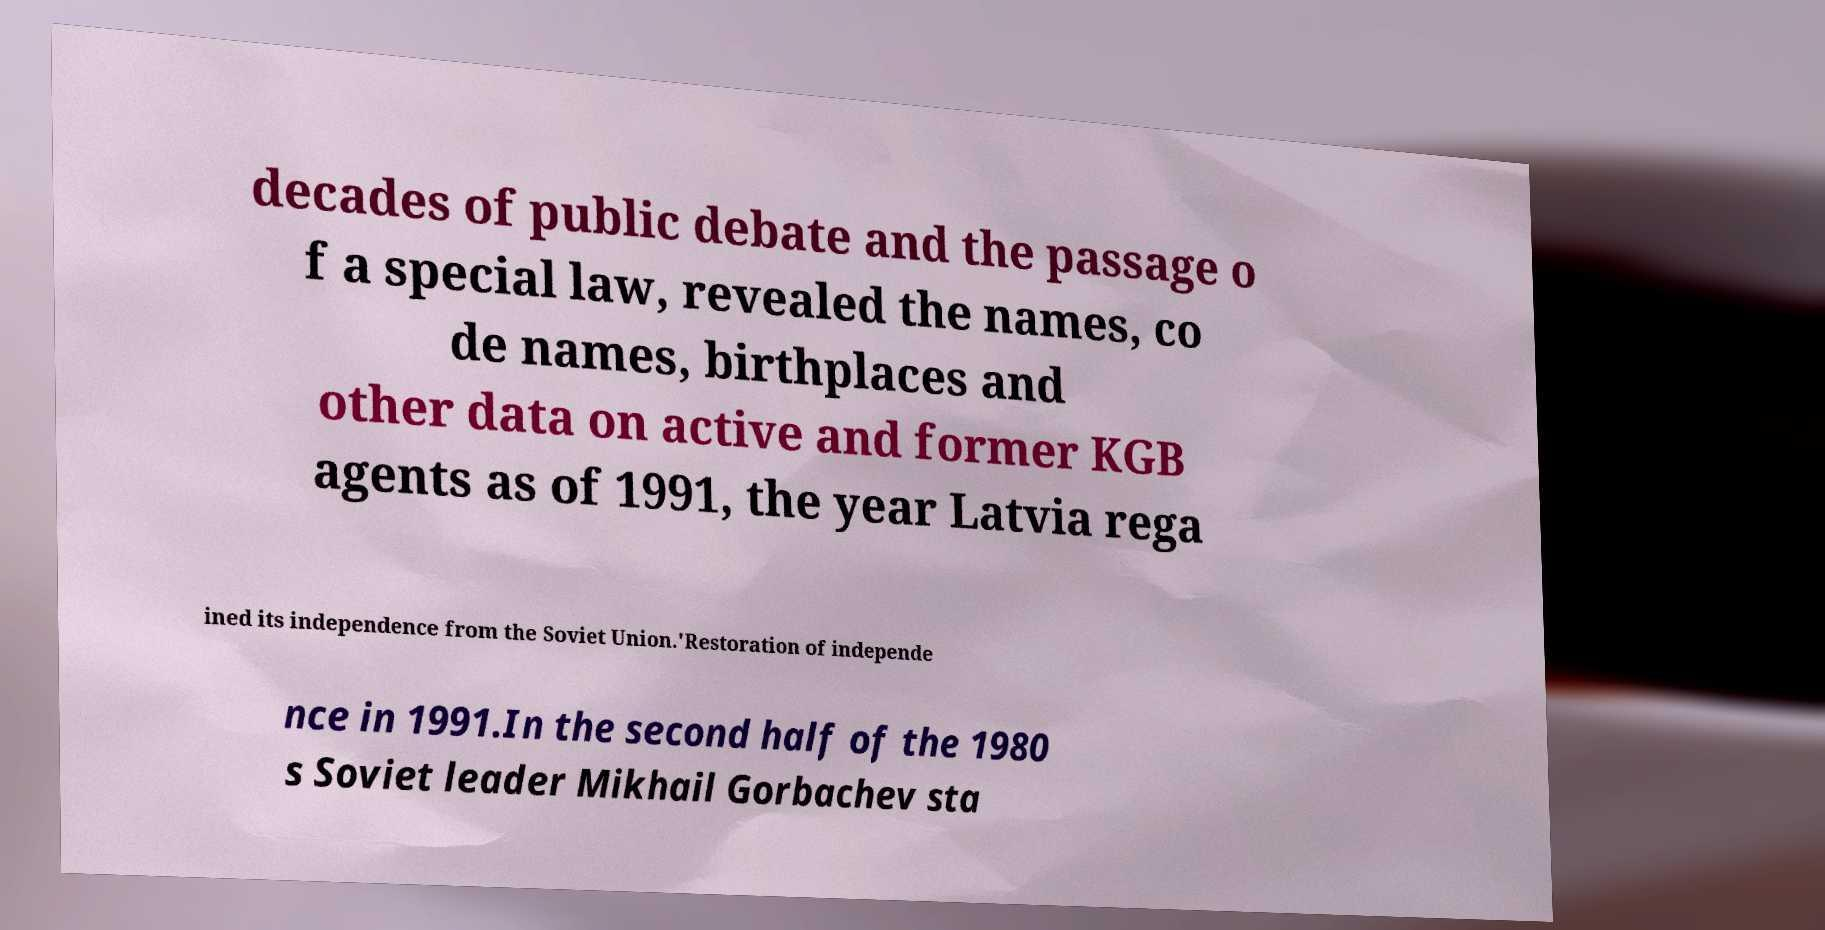There's text embedded in this image that I need extracted. Can you transcribe it verbatim? decades of public debate and the passage o f a special law, revealed the names, co de names, birthplaces and other data on active and former KGB agents as of 1991, the year Latvia rega ined its independence from the Soviet Union.'Restoration of independe nce in 1991.In the second half of the 1980 s Soviet leader Mikhail Gorbachev sta 